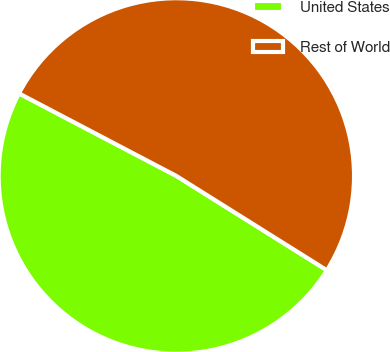Convert chart to OTSL. <chart><loc_0><loc_0><loc_500><loc_500><pie_chart><fcel>United States<fcel>Rest of World<nl><fcel>48.78%<fcel>51.22%<nl></chart> 